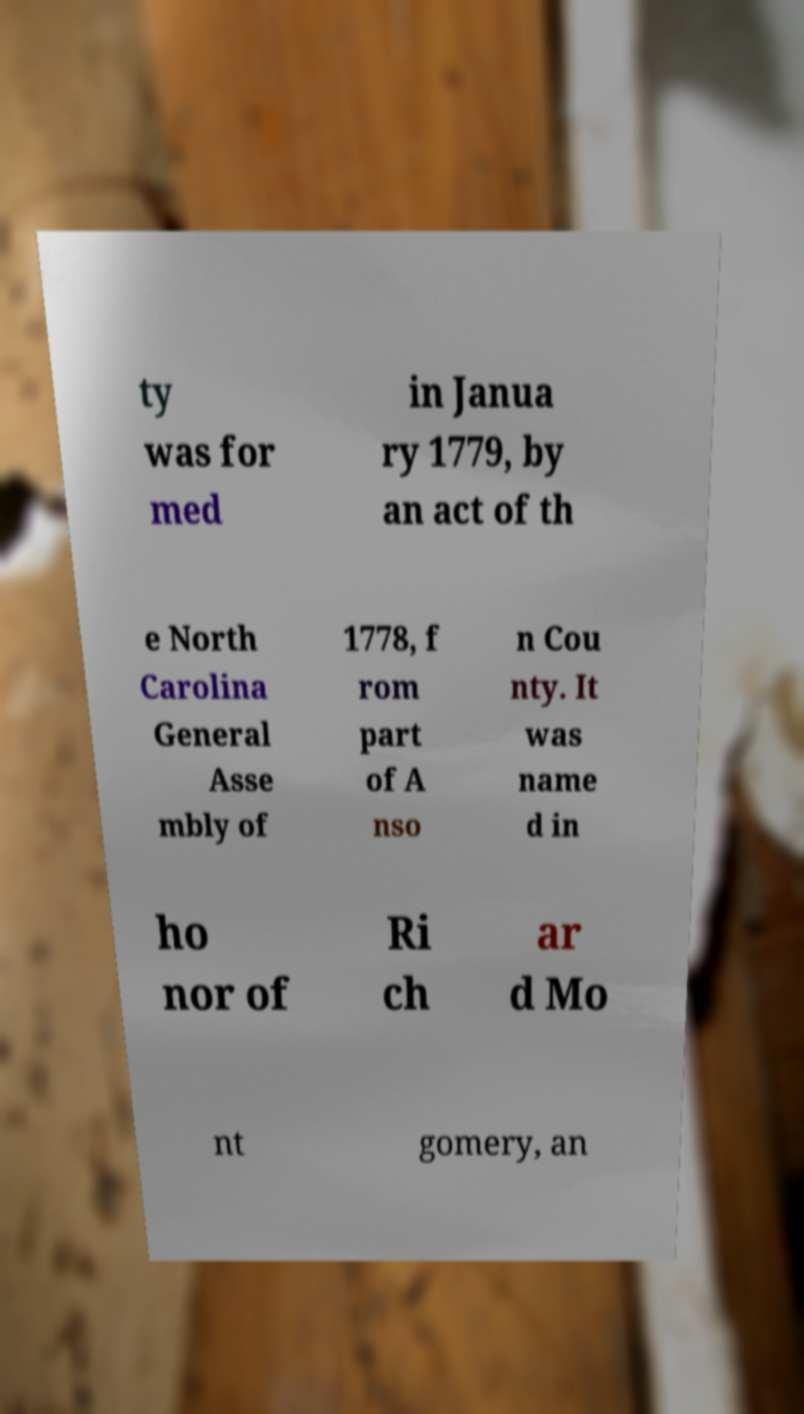Could you assist in decoding the text presented in this image and type it out clearly? ty was for med in Janua ry 1779, by an act of th e North Carolina General Asse mbly of 1778, f rom part of A nso n Cou nty. It was name d in ho nor of Ri ch ar d Mo nt gomery, an 